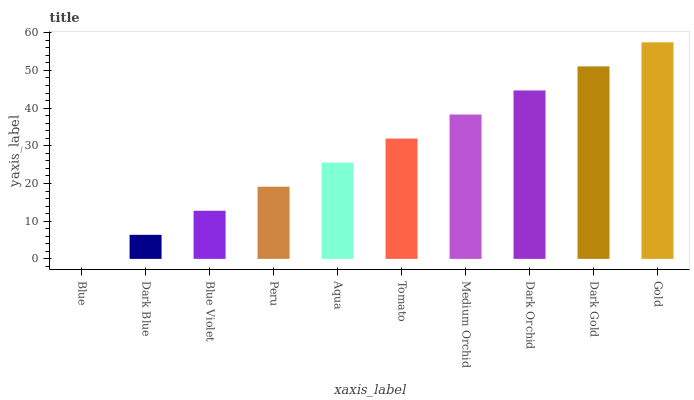Is Dark Blue the minimum?
Answer yes or no. No. Is Dark Blue the maximum?
Answer yes or no. No. Is Dark Blue greater than Blue?
Answer yes or no. Yes. Is Blue less than Dark Blue?
Answer yes or no. Yes. Is Blue greater than Dark Blue?
Answer yes or no. No. Is Dark Blue less than Blue?
Answer yes or no. No. Is Tomato the high median?
Answer yes or no. Yes. Is Aqua the low median?
Answer yes or no. Yes. Is Aqua the high median?
Answer yes or no. No. Is Dark Gold the low median?
Answer yes or no. No. 